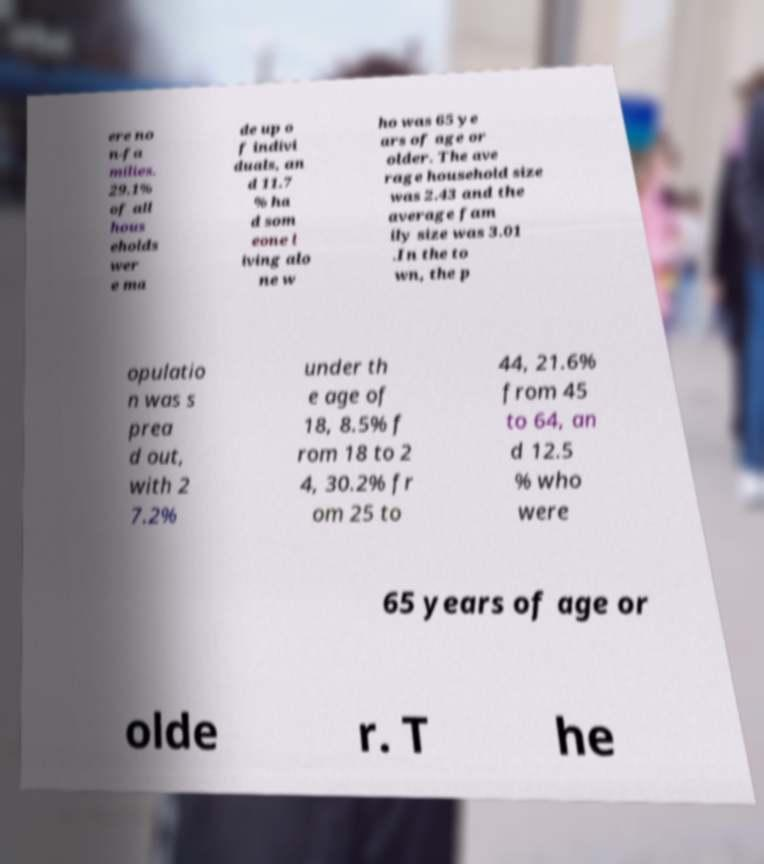Please identify and transcribe the text found in this image. ere no n-fa milies. 29.1% of all hous eholds wer e ma de up o f indivi duals, an d 11.7 % ha d som eone l iving alo ne w ho was 65 ye ars of age or older. The ave rage household size was 2.43 and the average fam ily size was 3.01 .In the to wn, the p opulatio n was s prea d out, with 2 7.2% under th e age of 18, 8.5% f rom 18 to 2 4, 30.2% fr om 25 to 44, 21.6% from 45 to 64, an d 12.5 % who were 65 years of age or olde r. T he 